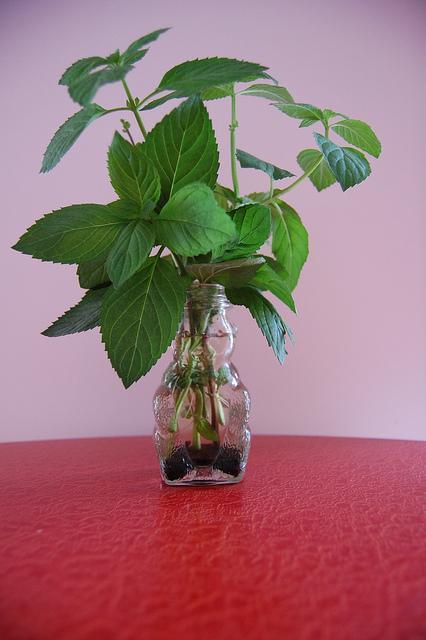How many clear containers are there?
Give a very brief answer. 1. How many flower arrangements are in the scene?
Give a very brief answer. 1. How many ties is this man wearing?
Give a very brief answer. 0. 